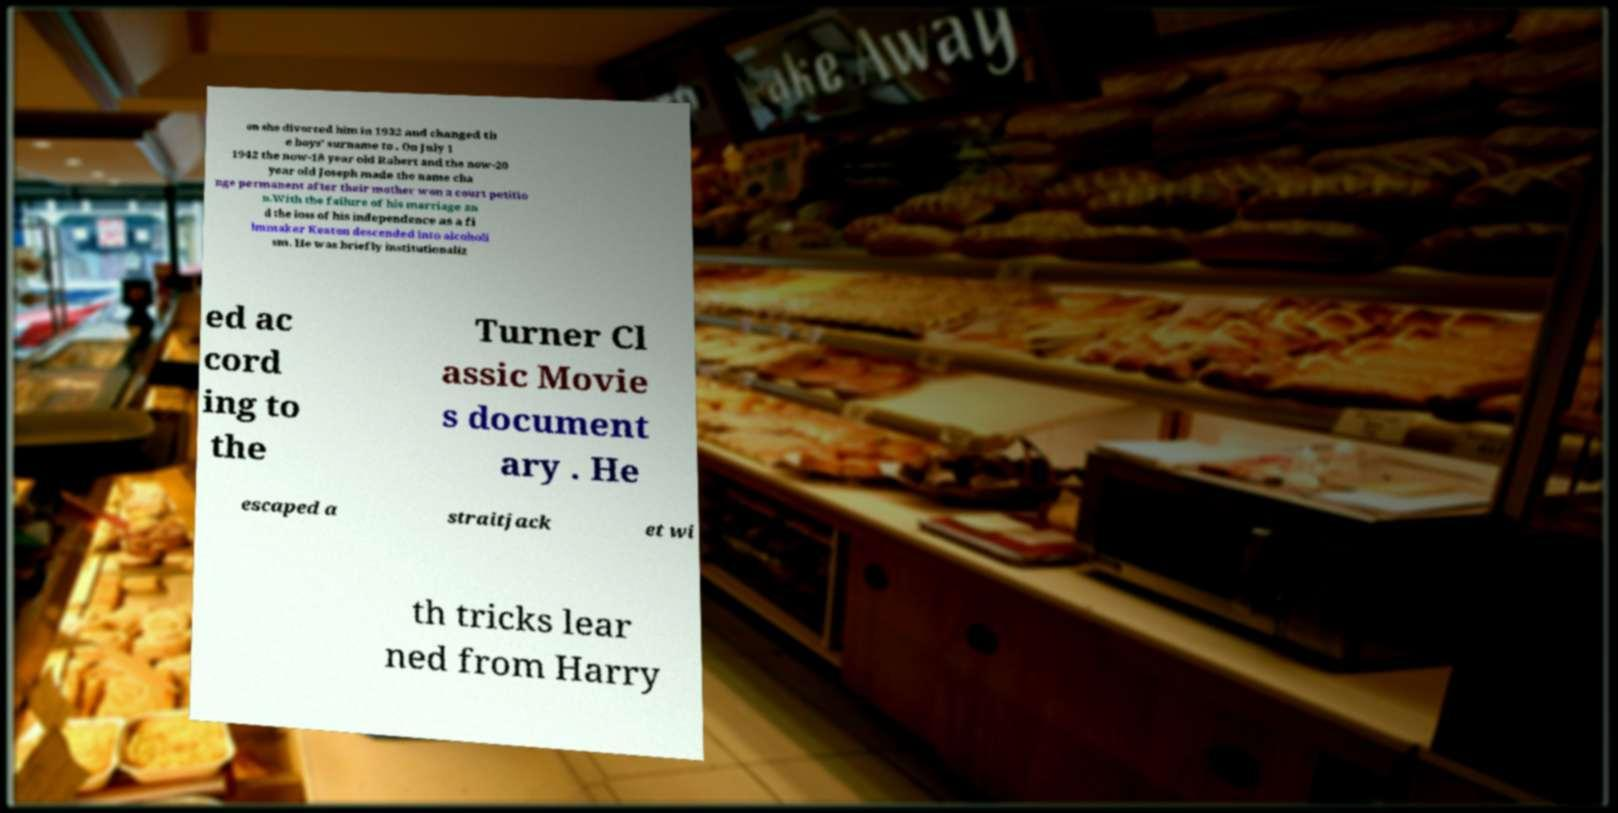There's text embedded in this image that I need extracted. Can you transcribe it verbatim? on she divorced him in 1932 and changed th e boys' surname to . On July 1 1942 the now-18 year old Robert and the now-20 year old Joseph made the name cha nge permanent after their mother won a court petitio n.With the failure of his marriage an d the loss of his independence as a fi lmmaker Keaton descended into alcoholi sm. He was briefly institutionaliz ed ac cord ing to the Turner Cl assic Movie s document ary . He escaped a straitjack et wi th tricks lear ned from Harry 